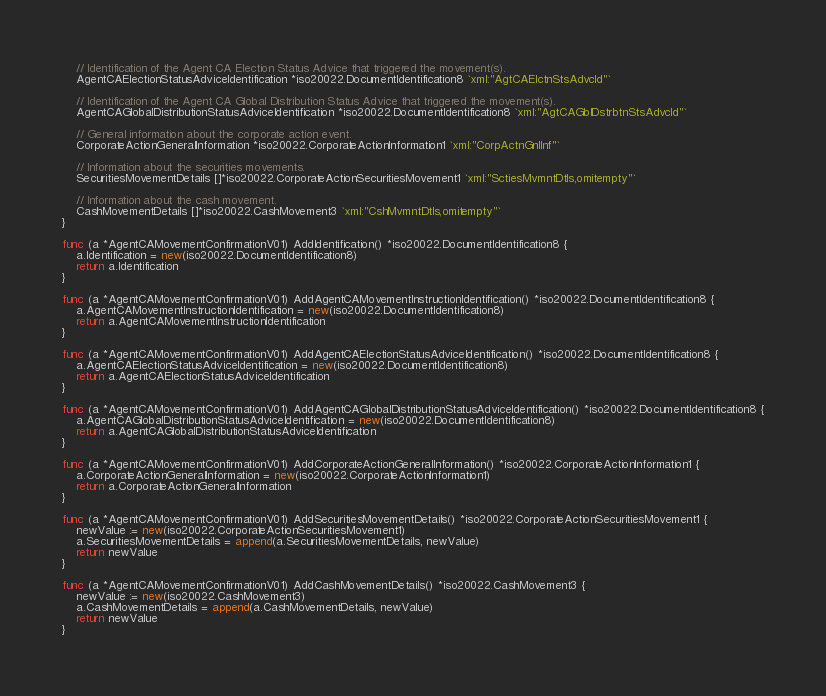<code> <loc_0><loc_0><loc_500><loc_500><_Go_>
	// Identification of the Agent CA Election Status Advice that triggered the movement(s).
	AgentCAElectionStatusAdviceIdentification *iso20022.DocumentIdentification8 `xml:"AgtCAElctnStsAdvcId"`

	// Identification of the Agent CA Global Distribution Status Advice that triggered the movement(s).
	AgentCAGlobalDistributionStatusAdviceIdentification *iso20022.DocumentIdentification8 `xml:"AgtCAGblDstrbtnStsAdvcId"`

	// General information about the corporate action event.
	CorporateActionGeneralInformation *iso20022.CorporateActionInformation1 `xml:"CorpActnGnlInf"`

	// Information about the securities movements.
	SecuritiesMovementDetails []*iso20022.CorporateActionSecuritiesMovement1 `xml:"SctiesMvmntDtls,omitempty"`

	// Information about the cash movement.
	CashMovementDetails []*iso20022.CashMovement3 `xml:"CshMvmntDtls,omitempty"`
}

func (a *AgentCAMovementConfirmationV01) AddIdentification() *iso20022.DocumentIdentification8 {
	a.Identification = new(iso20022.DocumentIdentification8)
	return a.Identification
}

func (a *AgentCAMovementConfirmationV01) AddAgentCAMovementInstructionIdentification() *iso20022.DocumentIdentification8 {
	a.AgentCAMovementInstructionIdentification = new(iso20022.DocumentIdentification8)
	return a.AgentCAMovementInstructionIdentification
}

func (a *AgentCAMovementConfirmationV01) AddAgentCAElectionStatusAdviceIdentification() *iso20022.DocumentIdentification8 {
	a.AgentCAElectionStatusAdviceIdentification = new(iso20022.DocumentIdentification8)
	return a.AgentCAElectionStatusAdviceIdentification
}

func (a *AgentCAMovementConfirmationV01) AddAgentCAGlobalDistributionStatusAdviceIdentification() *iso20022.DocumentIdentification8 {
	a.AgentCAGlobalDistributionStatusAdviceIdentification = new(iso20022.DocumentIdentification8)
	return a.AgentCAGlobalDistributionStatusAdviceIdentification
}

func (a *AgentCAMovementConfirmationV01) AddCorporateActionGeneralInformation() *iso20022.CorporateActionInformation1 {
	a.CorporateActionGeneralInformation = new(iso20022.CorporateActionInformation1)
	return a.CorporateActionGeneralInformation
}

func (a *AgentCAMovementConfirmationV01) AddSecuritiesMovementDetails() *iso20022.CorporateActionSecuritiesMovement1 {
	newValue := new(iso20022.CorporateActionSecuritiesMovement1)
	a.SecuritiesMovementDetails = append(a.SecuritiesMovementDetails, newValue)
	return newValue
}

func (a *AgentCAMovementConfirmationV01) AddCashMovementDetails() *iso20022.CashMovement3 {
	newValue := new(iso20022.CashMovement3)
	a.CashMovementDetails = append(a.CashMovementDetails, newValue)
	return newValue
}</code> 